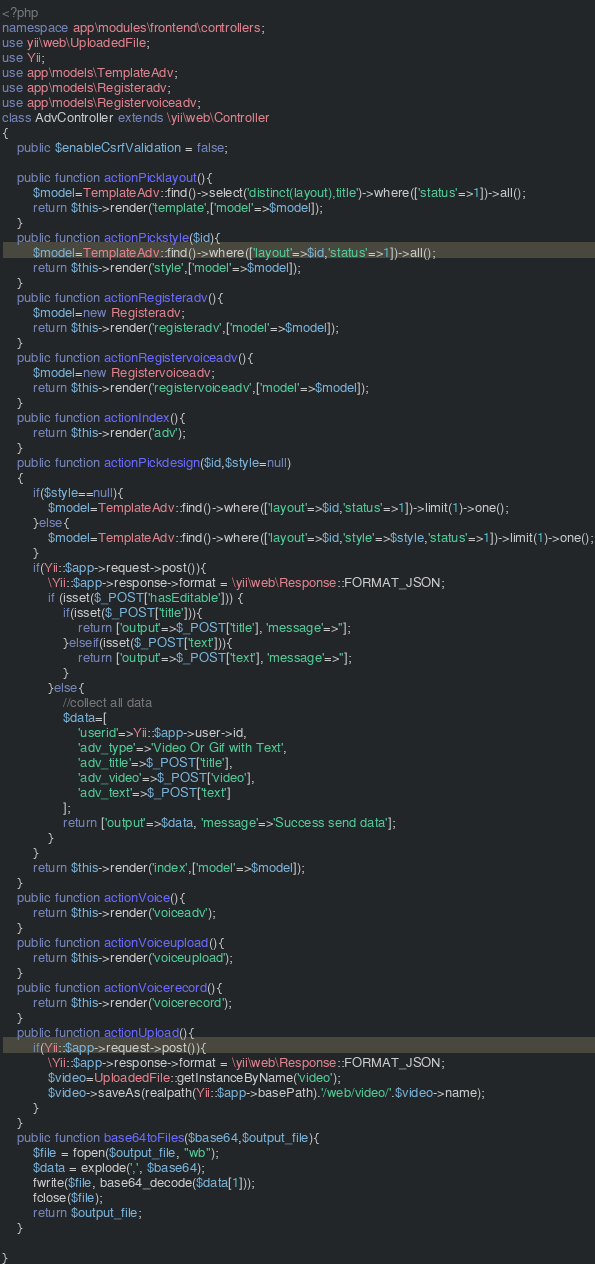<code> <loc_0><loc_0><loc_500><loc_500><_PHP_><?php
namespace app\modules\frontend\controllers;
use yii\web\UploadedFile;
use Yii;
use app\models\TemplateAdv;
use app\models\Registeradv;
use app\models\Registervoiceadv;
class AdvController extends \yii\web\Controller
{
	public $enableCsrfValidation = false;
	
	public function actionPicklayout(){
		$model=TemplateAdv::find()->select('distinct(layout),title')->where(['status'=>1])->all();
		return $this->render('template',['model'=>$model]);
	}
	public function actionPickstyle($id){
		$model=TemplateAdv::find()->where(['layout'=>$id,'status'=>1])->all();
		return $this->render('style',['model'=>$model]);
	}
	public function actionRegisteradv(){
		$model=new Registeradv;
		return $this->render('registeradv',['model'=>$model]);
	}
	public function actionRegistervoiceadv(){
		$model=new Registervoiceadv;
		return $this->render('registervoiceadv',['model'=>$model]);
	}
    public function actionIndex(){
    	return $this->render('adv');
    }
    public function actionPickdesign($id,$style=null)
    {
    	if($style==null){
    		$model=TemplateAdv::find()->where(['layout'=>$id,'status'=>1])->limit(1)->one();
    	}else{
    		$model=TemplateAdv::find()->where(['layout'=>$id,'style'=>$style,'status'=>1])->limit(1)->one();
    	}
    	if(Yii::$app->request->post()){
    		\Yii::$app->response->format = \yii\web\Response::FORMAT_JSON;
    		if (isset($_POST['hasEditable'])) {
	    		if(isset($_POST['title'])){
	    			return ['output'=>$_POST['title'], 'message'=>''];
	    		}elseif(isset($_POST['text'])){
	    			return ['output'=>$_POST['text'], 'message'=>''];
	    		}
	    	}else{
	    		//collect all data
	    		$data=[
	    			'userid'=>Yii::$app->user->id,
	    			'adv_type'=>'Video Or Gif with Text',
	    			'adv_title'=>$_POST['title'],
	    			'adv_video'=>$_POST['video'],
	    			'adv_text'=>$_POST['text']
	    		];
	    		return ['output'=>$data, 'message'=>'Success send data'];
	    	}
    	}
        return $this->render('index',['model'=>$model]);
    }
    public function actionVoice(){
    	return $this->render('voiceadv');
    }
    public function actionVoiceupload(){
    	return $this->render('voiceupload');
    }
    public function actionVoicerecord(){
    	return $this->render('voicerecord');
    }
    public function actionUpload(){
    	if(Yii::$app->request->post()){
	    	\Yii::$app->response->format = \yii\web\Response::FORMAT_JSON;
	    	$video=UploadedFile::getInstanceByName('video');
	    	$video->saveAs(realpath(Yii::$app->basePath).'/web/video/'.$video->name);
	    }
    }
    public function base64toFiles($base64,$output_file){
        $file = fopen($output_file, "wb");
        $data = explode(',', $base64);
        fwrite($file, base64_decode($data[1]));
        fclose($file);
        return $output_file;
    }

}
</code> 